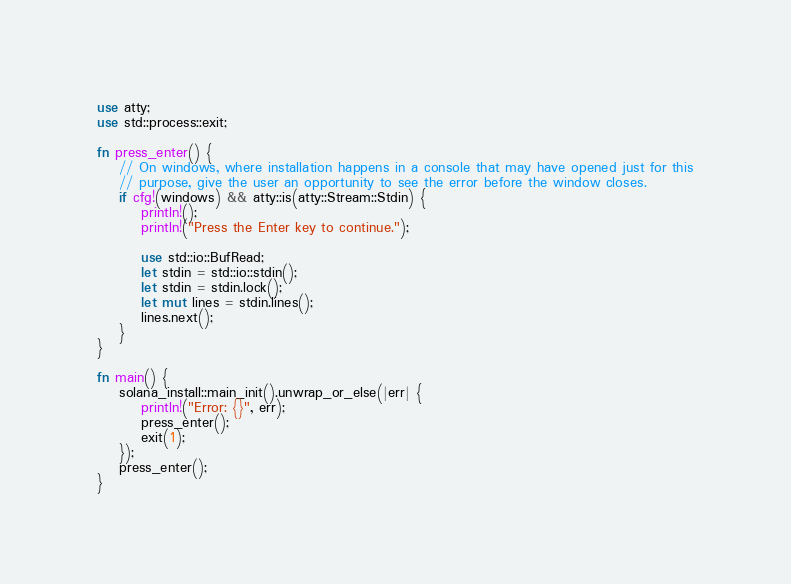Convert code to text. <code><loc_0><loc_0><loc_500><loc_500><_Rust_>use atty;
use std::process::exit;

fn press_enter() {
    // On windows, where installation happens in a console that may have opened just for this
    // purpose, give the user an opportunity to see the error before the window closes.
    if cfg!(windows) && atty::is(atty::Stream::Stdin) {
        println!();
        println!("Press the Enter key to continue.");

        use std::io::BufRead;
        let stdin = std::io::stdin();
        let stdin = stdin.lock();
        let mut lines = stdin.lines();
        lines.next();
    }
}

fn main() {
    solana_install::main_init().unwrap_or_else(|err| {
        println!("Error: {}", err);
        press_enter();
        exit(1);
    });
    press_enter();
}
</code> 